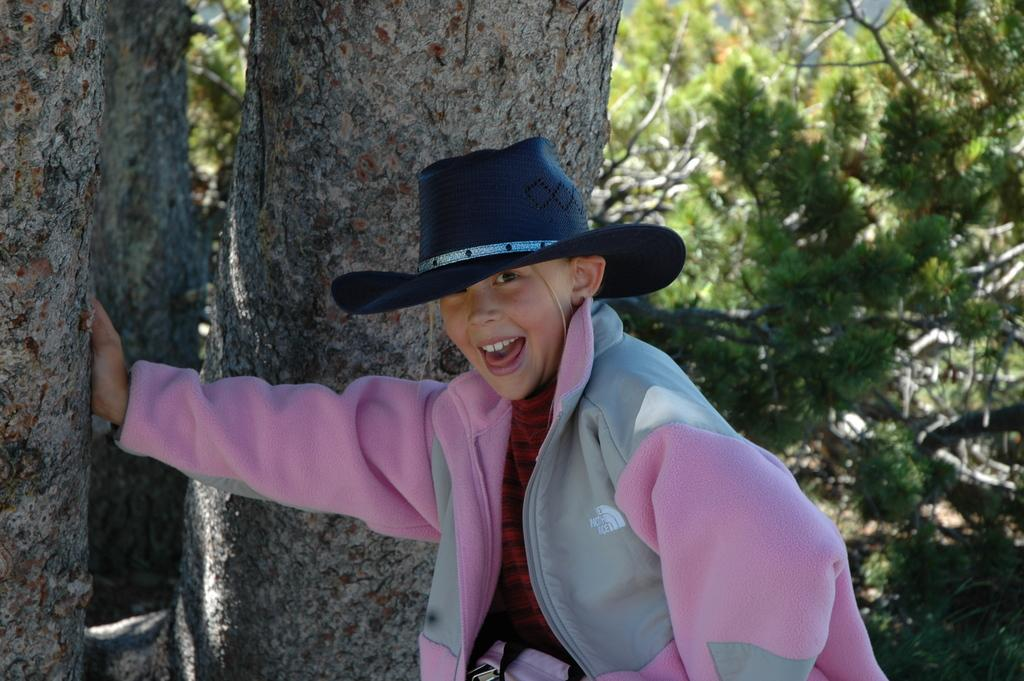What is the main subject of the image? The main subject of the image is a kid. What is the kid wearing in the image? The kid is wearing a jacket and a hat in the image. What is the kid doing in the image? The kid has his hand on a tree trunk in the image. What can be seen in the background of the image? There are trees in the background of the image. What is the size of the copper aftermath in the image? There is no copper or aftermath present in the image; it features a kid with a jacket, hat, and hand on a tree trunk, with trees in the background. 